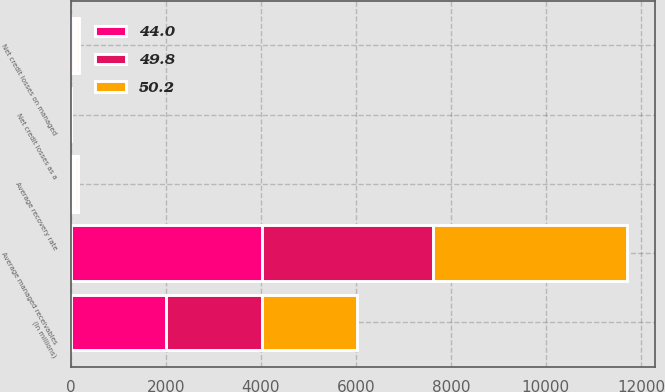Convert chart. <chart><loc_0><loc_0><loc_500><loc_500><stacked_bar_chart><ecel><fcel>(In millions)<fcel>Net credit losses on managed<fcel>Average managed receivables<fcel>Net credit losses as a<fcel>Average recovery rate<nl><fcel>50.2<fcel>2010<fcel>70.1<fcel>4080<fcel>1.72<fcel>49.8<nl><fcel>44<fcel>2009<fcel>69.8<fcel>4021<fcel>1.74<fcel>44<nl><fcel>49.8<fcel>2008<fcel>38.3<fcel>3608.4<fcel>1.06<fcel>50.2<nl></chart> 